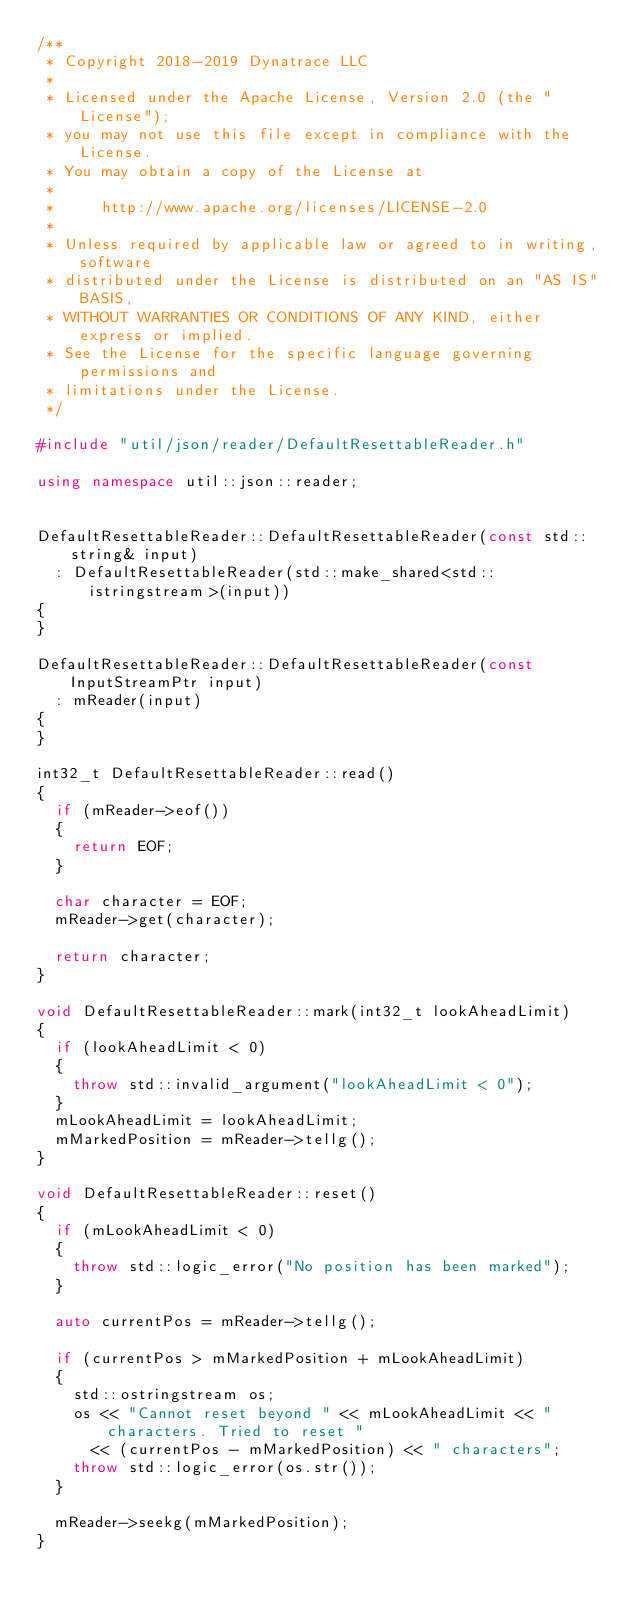Convert code to text. <code><loc_0><loc_0><loc_500><loc_500><_C++_>/**
 * Copyright 2018-2019 Dynatrace LLC
 *
 * Licensed under the Apache License, Version 2.0 (the "License");
 * you may not use this file except in compliance with the License.
 * You may obtain a copy of the License at
 *
 *     http://www.apache.org/licenses/LICENSE-2.0
 *
 * Unless required by applicable law or agreed to in writing, software
 * distributed under the License is distributed on an "AS IS" BASIS,
 * WITHOUT WARRANTIES OR CONDITIONS OF ANY KIND, either express or implied.
 * See the License for the specific language governing permissions and
 * limitations under the License.
 */

#include "util/json/reader/DefaultResettableReader.h"

using namespace util::json::reader;


DefaultResettableReader::DefaultResettableReader(const std::string& input)
	: DefaultResettableReader(std::make_shared<std::istringstream>(input))
{
}

DefaultResettableReader::DefaultResettableReader(const InputStreamPtr input)
	: mReader(input)
{
}

int32_t DefaultResettableReader::read()
{
	if (mReader->eof())
	{
		return EOF;
	}

	char character = EOF;
	mReader->get(character);

	return character;
}

void DefaultResettableReader::mark(int32_t lookAheadLimit)
{
	if (lookAheadLimit < 0)
	{
		throw std::invalid_argument("lookAheadLimit < 0");
	}
	mLookAheadLimit = lookAheadLimit;
	mMarkedPosition = mReader->tellg();
}

void DefaultResettableReader::reset()
{
	if (mLookAheadLimit < 0)
	{
		throw std::logic_error("No position has been marked");
	}

	auto currentPos = mReader->tellg();

	if (currentPos > mMarkedPosition + mLookAheadLimit)
	{
		std::ostringstream os;
		os << "Cannot reset beyond " << mLookAheadLimit << " characters. Tried to reset "
			<< (currentPos - mMarkedPosition) << " characters";
		throw std::logic_error(os.str());
	}

	mReader->seekg(mMarkedPosition);
}</code> 